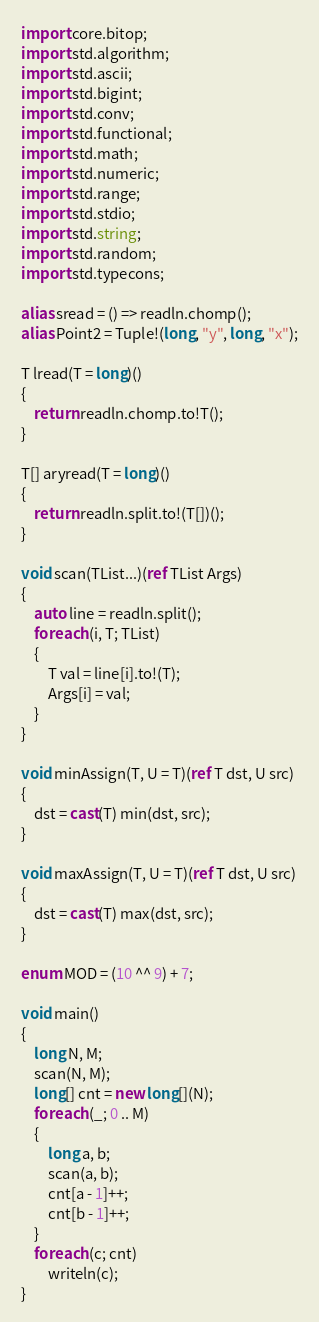Convert code to text. <code><loc_0><loc_0><loc_500><loc_500><_D_>import core.bitop;
import std.algorithm;
import std.ascii;
import std.bigint;
import std.conv;
import std.functional;
import std.math;
import std.numeric;
import std.range;
import std.stdio;
import std.string;
import std.random;
import std.typecons;

alias sread = () => readln.chomp();
alias Point2 = Tuple!(long, "y", long, "x");

T lread(T = long)()
{
    return readln.chomp.to!T();
}

T[] aryread(T = long)()
{
    return readln.split.to!(T[])();
}

void scan(TList...)(ref TList Args)
{
    auto line = readln.split();
    foreach (i, T; TList)
    {
        T val = line[i].to!(T);
        Args[i] = val;
    }
}

void minAssign(T, U = T)(ref T dst, U src)
{
    dst = cast(T) min(dst, src);
}

void maxAssign(T, U = T)(ref T dst, U src)
{
    dst = cast(T) max(dst, src);
}

enum MOD = (10 ^^ 9) + 7;

void main()
{
    long N, M;
    scan(N, M);
    long[] cnt = new long[](N);
    foreach (_; 0 .. M)
    {
        long a, b;
        scan(a, b);
        cnt[a - 1]++;
        cnt[b - 1]++;
    }
    foreach (c; cnt)
        writeln(c);
}
</code> 